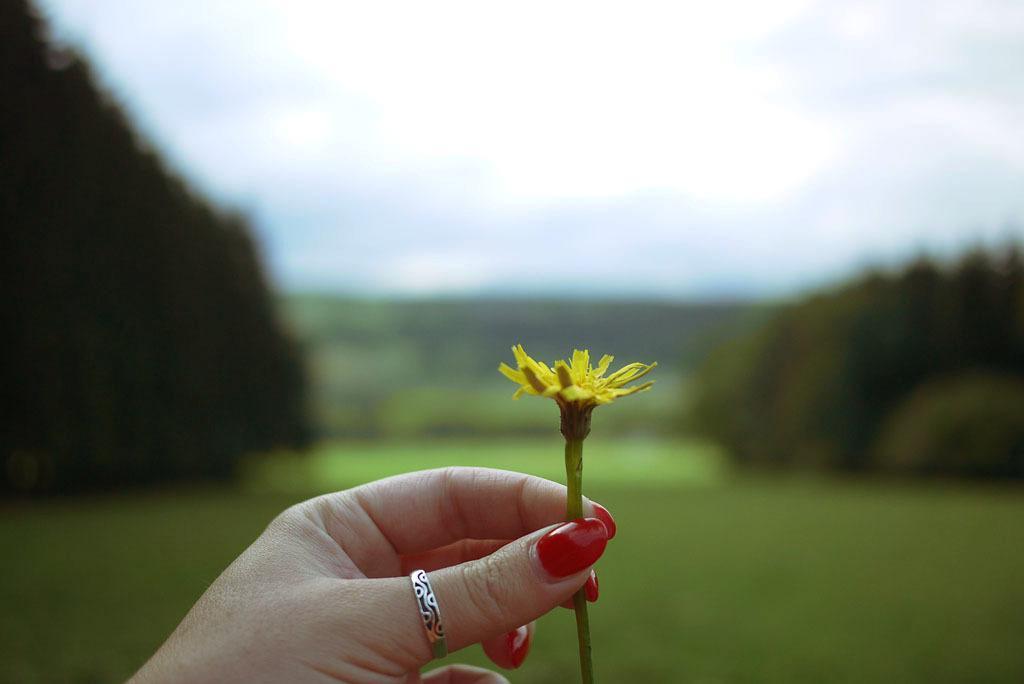Please provide a concise description of this image. In this image we can see hand of a person holding flower. Also there is ring on the finger. In the background it is blur. 